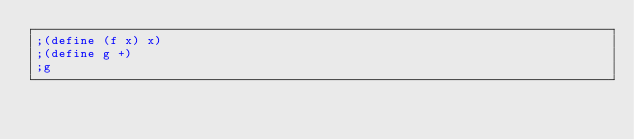<code> <loc_0><loc_0><loc_500><loc_500><_Racket_>;(define (f x) x)
;(define g +)
;g
</code> 